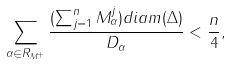Convert formula to latex. <formula><loc_0><loc_0><loc_500><loc_500>\sum _ { \alpha \in R _ { M ^ { + } } } \frac { ( \sum _ { j = 1 } ^ { n } M _ { \alpha } ^ { j } ) d i a m ( \Delta ) } { D _ { \alpha } } < \frac { n } { 4 } ,</formula> 